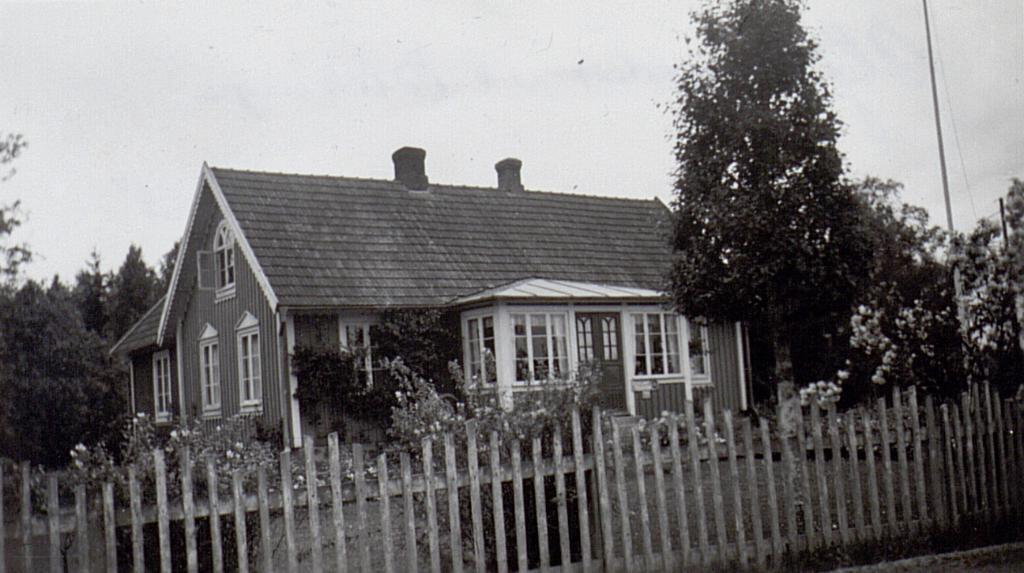What is the color scheme of the image? The image is black and white. What is the main subject in the center of the image? There is a house in the center of the image. What can be seen at the bottom of the image? There is fencing and plants at the bottom of the image. What is visible in the background of the image? There are trees and the sky in the background of the image. What type of development is taking place in the image? There is no development taking place in the image; it is a static scene featuring a house, fencing, plants, trees, and the sky. Is there a tent visible in the image? No, there is no tent present in the image. 